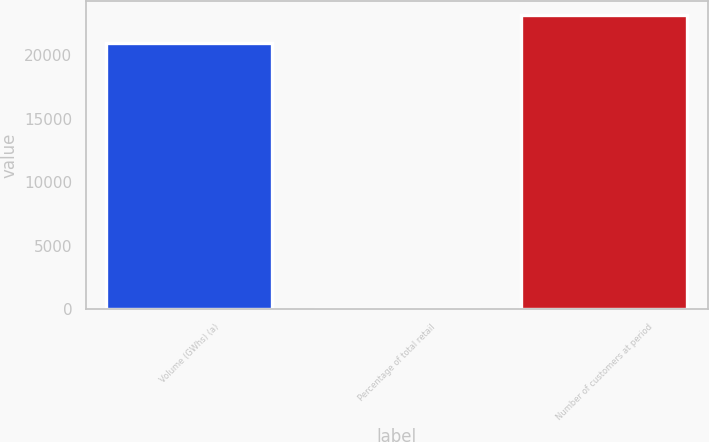Convert chart to OTSL. <chart><loc_0><loc_0><loc_500><loc_500><bar_chart><fcel>Volume (GWhs) (a)<fcel>Percentage of total retail<fcel>Number of customers at period<nl><fcel>20939<fcel>24<fcel>23152.7<nl></chart> 